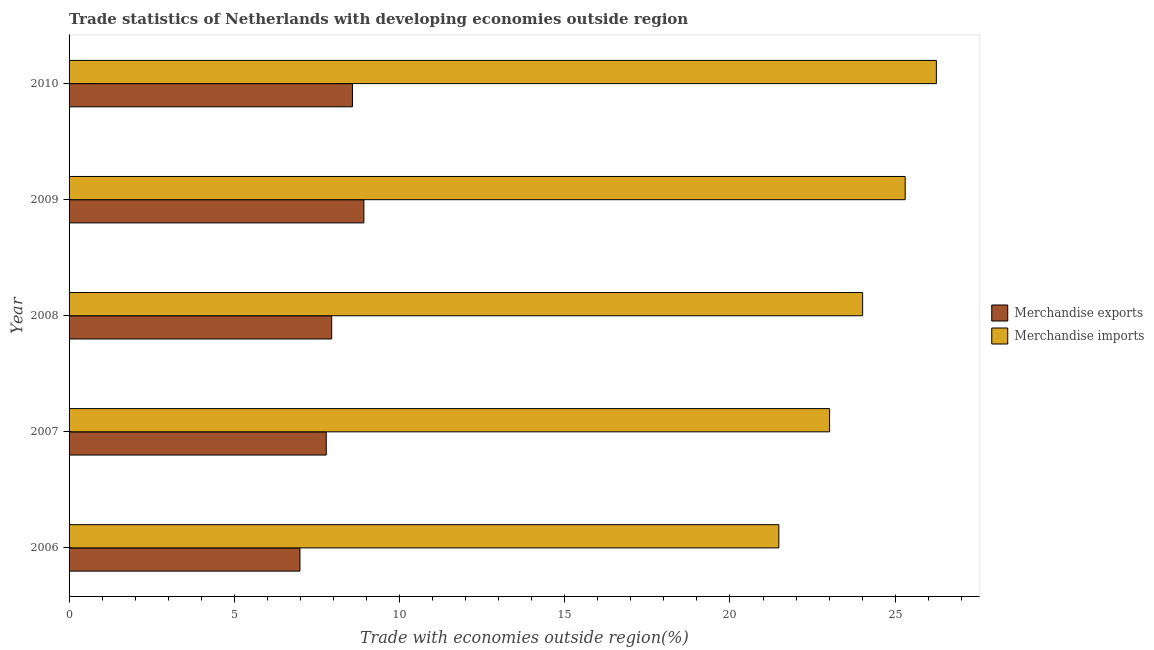How many different coloured bars are there?
Keep it short and to the point. 2. How many groups of bars are there?
Ensure brevity in your answer.  5. Are the number of bars per tick equal to the number of legend labels?
Give a very brief answer. Yes. Are the number of bars on each tick of the Y-axis equal?
Provide a succinct answer. Yes. How many bars are there on the 1st tick from the top?
Give a very brief answer. 2. What is the label of the 4th group of bars from the top?
Keep it short and to the point. 2007. What is the merchandise imports in 2006?
Offer a very short reply. 21.48. Across all years, what is the maximum merchandise exports?
Keep it short and to the point. 8.92. Across all years, what is the minimum merchandise exports?
Ensure brevity in your answer.  6.99. In which year was the merchandise imports maximum?
Provide a short and direct response. 2010. In which year was the merchandise exports minimum?
Your answer should be very brief. 2006. What is the total merchandise exports in the graph?
Provide a short and direct response. 40.21. What is the difference between the merchandise exports in 2007 and that in 2009?
Provide a succinct answer. -1.14. What is the difference between the merchandise exports in 2006 and the merchandise imports in 2010?
Your answer should be very brief. -19.26. What is the average merchandise imports per year?
Ensure brevity in your answer.  24.01. In the year 2008, what is the difference between the merchandise exports and merchandise imports?
Your answer should be compact. -16.07. What is the ratio of the merchandise imports in 2006 to that in 2007?
Your response must be concise. 0.93. Is the merchandise exports in 2006 less than that in 2007?
Your answer should be very brief. Yes. Is the difference between the merchandise imports in 2008 and 2010 greater than the difference between the merchandise exports in 2008 and 2010?
Offer a terse response. No. What is the difference between the highest and the second highest merchandise exports?
Provide a succinct answer. 0.35. What is the difference between the highest and the lowest merchandise exports?
Your answer should be very brief. 1.93. In how many years, is the merchandise exports greater than the average merchandise exports taken over all years?
Keep it short and to the point. 2. Is the sum of the merchandise exports in 2008 and 2009 greater than the maximum merchandise imports across all years?
Your response must be concise. No. What does the 1st bar from the top in 2007 represents?
Give a very brief answer. Merchandise imports. What does the 2nd bar from the bottom in 2006 represents?
Offer a terse response. Merchandise imports. How many bars are there?
Keep it short and to the point. 10. How many years are there in the graph?
Ensure brevity in your answer.  5. What is the difference between two consecutive major ticks on the X-axis?
Ensure brevity in your answer.  5. Are the values on the major ticks of X-axis written in scientific E-notation?
Make the answer very short. No. Where does the legend appear in the graph?
Your answer should be very brief. Center right. What is the title of the graph?
Your answer should be very brief. Trade statistics of Netherlands with developing economies outside region. Does "Commercial service imports" appear as one of the legend labels in the graph?
Provide a short and direct response. No. What is the label or title of the X-axis?
Your answer should be very brief. Trade with economies outside region(%). What is the label or title of the Y-axis?
Provide a short and direct response. Year. What is the Trade with economies outside region(%) in Merchandise exports in 2006?
Offer a terse response. 6.99. What is the Trade with economies outside region(%) of Merchandise imports in 2006?
Offer a very short reply. 21.48. What is the Trade with economies outside region(%) in Merchandise exports in 2007?
Ensure brevity in your answer.  7.78. What is the Trade with economies outside region(%) of Merchandise imports in 2007?
Your answer should be compact. 23.01. What is the Trade with economies outside region(%) in Merchandise exports in 2008?
Offer a terse response. 7.95. What is the Trade with economies outside region(%) in Merchandise imports in 2008?
Give a very brief answer. 24.01. What is the Trade with economies outside region(%) in Merchandise exports in 2009?
Your answer should be compact. 8.92. What is the Trade with economies outside region(%) of Merchandise imports in 2009?
Your response must be concise. 25.3. What is the Trade with economies outside region(%) in Merchandise exports in 2010?
Provide a succinct answer. 8.58. What is the Trade with economies outside region(%) of Merchandise imports in 2010?
Offer a terse response. 26.24. Across all years, what is the maximum Trade with economies outside region(%) in Merchandise exports?
Provide a short and direct response. 8.92. Across all years, what is the maximum Trade with economies outside region(%) of Merchandise imports?
Your answer should be very brief. 26.24. Across all years, what is the minimum Trade with economies outside region(%) of Merchandise exports?
Provide a short and direct response. 6.99. Across all years, what is the minimum Trade with economies outside region(%) in Merchandise imports?
Offer a very short reply. 21.48. What is the total Trade with economies outside region(%) of Merchandise exports in the graph?
Your answer should be compact. 40.21. What is the total Trade with economies outside region(%) in Merchandise imports in the graph?
Offer a very short reply. 120.05. What is the difference between the Trade with economies outside region(%) in Merchandise exports in 2006 and that in 2007?
Provide a short and direct response. -0.8. What is the difference between the Trade with economies outside region(%) in Merchandise imports in 2006 and that in 2007?
Ensure brevity in your answer.  -1.53. What is the difference between the Trade with economies outside region(%) in Merchandise exports in 2006 and that in 2008?
Offer a terse response. -0.96. What is the difference between the Trade with economies outside region(%) in Merchandise imports in 2006 and that in 2008?
Offer a very short reply. -2.54. What is the difference between the Trade with economies outside region(%) of Merchandise exports in 2006 and that in 2009?
Make the answer very short. -1.93. What is the difference between the Trade with economies outside region(%) in Merchandise imports in 2006 and that in 2009?
Offer a terse response. -3.82. What is the difference between the Trade with economies outside region(%) of Merchandise exports in 2006 and that in 2010?
Your answer should be compact. -1.59. What is the difference between the Trade with economies outside region(%) in Merchandise imports in 2006 and that in 2010?
Offer a very short reply. -4.77. What is the difference between the Trade with economies outside region(%) in Merchandise exports in 2007 and that in 2008?
Make the answer very short. -0.16. What is the difference between the Trade with economies outside region(%) in Merchandise imports in 2007 and that in 2008?
Your response must be concise. -1. What is the difference between the Trade with economies outside region(%) of Merchandise exports in 2007 and that in 2009?
Offer a terse response. -1.14. What is the difference between the Trade with economies outside region(%) of Merchandise imports in 2007 and that in 2009?
Your answer should be very brief. -2.29. What is the difference between the Trade with economies outside region(%) of Merchandise exports in 2007 and that in 2010?
Give a very brief answer. -0.79. What is the difference between the Trade with economies outside region(%) in Merchandise imports in 2007 and that in 2010?
Give a very brief answer. -3.23. What is the difference between the Trade with economies outside region(%) of Merchandise exports in 2008 and that in 2009?
Provide a succinct answer. -0.97. What is the difference between the Trade with economies outside region(%) in Merchandise imports in 2008 and that in 2009?
Your answer should be compact. -1.29. What is the difference between the Trade with economies outside region(%) in Merchandise exports in 2008 and that in 2010?
Your answer should be very brief. -0.63. What is the difference between the Trade with economies outside region(%) in Merchandise imports in 2008 and that in 2010?
Provide a succinct answer. -2.23. What is the difference between the Trade with economies outside region(%) of Merchandise exports in 2009 and that in 2010?
Your answer should be very brief. 0.35. What is the difference between the Trade with economies outside region(%) in Merchandise imports in 2009 and that in 2010?
Provide a short and direct response. -0.94. What is the difference between the Trade with economies outside region(%) of Merchandise exports in 2006 and the Trade with economies outside region(%) of Merchandise imports in 2007?
Your answer should be very brief. -16.03. What is the difference between the Trade with economies outside region(%) in Merchandise exports in 2006 and the Trade with economies outside region(%) in Merchandise imports in 2008?
Your answer should be compact. -17.03. What is the difference between the Trade with economies outside region(%) of Merchandise exports in 2006 and the Trade with economies outside region(%) of Merchandise imports in 2009?
Make the answer very short. -18.32. What is the difference between the Trade with economies outside region(%) of Merchandise exports in 2006 and the Trade with economies outside region(%) of Merchandise imports in 2010?
Your response must be concise. -19.26. What is the difference between the Trade with economies outside region(%) in Merchandise exports in 2007 and the Trade with economies outside region(%) in Merchandise imports in 2008?
Give a very brief answer. -16.23. What is the difference between the Trade with economies outside region(%) in Merchandise exports in 2007 and the Trade with economies outside region(%) in Merchandise imports in 2009?
Provide a succinct answer. -17.52. What is the difference between the Trade with economies outside region(%) of Merchandise exports in 2007 and the Trade with economies outside region(%) of Merchandise imports in 2010?
Ensure brevity in your answer.  -18.46. What is the difference between the Trade with economies outside region(%) in Merchandise exports in 2008 and the Trade with economies outside region(%) in Merchandise imports in 2009?
Offer a terse response. -17.36. What is the difference between the Trade with economies outside region(%) of Merchandise exports in 2008 and the Trade with economies outside region(%) of Merchandise imports in 2010?
Offer a very short reply. -18.3. What is the difference between the Trade with economies outside region(%) in Merchandise exports in 2009 and the Trade with economies outside region(%) in Merchandise imports in 2010?
Your answer should be very brief. -17.32. What is the average Trade with economies outside region(%) in Merchandise exports per year?
Keep it short and to the point. 8.04. What is the average Trade with economies outside region(%) in Merchandise imports per year?
Your answer should be compact. 24.01. In the year 2006, what is the difference between the Trade with economies outside region(%) in Merchandise exports and Trade with economies outside region(%) in Merchandise imports?
Provide a succinct answer. -14.49. In the year 2007, what is the difference between the Trade with economies outside region(%) in Merchandise exports and Trade with economies outside region(%) in Merchandise imports?
Ensure brevity in your answer.  -15.23. In the year 2008, what is the difference between the Trade with economies outside region(%) of Merchandise exports and Trade with economies outside region(%) of Merchandise imports?
Offer a terse response. -16.07. In the year 2009, what is the difference between the Trade with economies outside region(%) in Merchandise exports and Trade with economies outside region(%) in Merchandise imports?
Ensure brevity in your answer.  -16.38. In the year 2010, what is the difference between the Trade with economies outside region(%) in Merchandise exports and Trade with economies outside region(%) in Merchandise imports?
Make the answer very short. -17.67. What is the ratio of the Trade with economies outside region(%) of Merchandise exports in 2006 to that in 2007?
Give a very brief answer. 0.9. What is the ratio of the Trade with economies outside region(%) of Merchandise imports in 2006 to that in 2007?
Keep it short and to the point. 0.93. What is the ratio of the Trade with economies outside region(%) of Merchandise exports in 2006 to that in 2008?
Provide a succinct answer. 0.88. What is the ratio of the Trade with economies outside region(%) in Merchandise imports in 2006 to that in 2008?
Make the answer very short. 0.89. What is the ratio of the Trade with economies outside region(%) in Merchandise exports in 2006 to that in 2009?
Provide a short and direct response. 0.78. What is the ratio of the Trade with economies outside region(%) in Merchandise imports in 2006 to that in 2009?
Your answer should be very brief. 0.85. What is the ratio of the Trade with economies outside region(%) of Merchandise exports in 2006 to that in 2010?
Keep it short and to the point. 0.81. What is the ratio of the Trade with economies outside region(%) of Merchandise imports in 2006 to that in 2010?
Provide a short and direct response. 0.82. What is the ratio of the Trade with economies outside region(%) in Merchandise exports in 2007 to that in 2008?
Offer a terse response. 0.98. What is the ratio of the Trade with economies outside region(%) of Merchandise exports in 2007 to that in 2009?
Give a very brief answer. 0.87. What is the ratio of the Trade with economies outside region(%) of Merchandise imports in 2007 to that in 2009?
Your response must be concise. 0.91. What is the ratio of the Trade with economies outside region(%) in Merchandise exports in 2007 to that in 2010?
Ensure brevity in your answer.  0.91. What is the ratio of the Trade with economies outside region(%) of Merchandise imports in 2007 to that in 2010?
Provide a succinct answer. 0.88. What is the ratio of the Trade with economies outside region(%) in Merchandise exports in 2008 to that in 2009?
Keep it short and to the point. 0.89. What is the ratio of the Trade with economies outside region(%) of Merchandise imports in 2008 to that in 2009?
Offer a very short reply. 0.95. What is the ratio of the Trade with economies outside region(%) of Merchandise exports in 2008 to that in 2010?
Keep it short and to the point. 0.93. What is the ratio of the Trade with economies outside region(%) in Merchandise imports in 2008 to that in 2010?
Your response must be concise. 0.92. What is the ratio of the Trade with economies outside region(%) of Merchandise exports in 2009 to that in 2010?
Offer a terse response. 1.04. What is the ratio of the Trade with economies outside region(%) of Merchandise imports in 2009 to that in 2010?
Offer a terse response. 0.96. What is the difference between the highest and the second highest Trade with economies outside region(%) of Merchandise exports?
Ensure brevity in your answer.  0.35. What is the difference between the highest and the second highest Trade with economies outside region(%) in Merchandise imports?
Your answer should be compact. 0.94. What is the difference between the highest and the lowest Trade with economies outside region(%) of Merchandise exports?
Your answer should be very brief. 1.93. What is the difference between the highest and the lowest Trade with economies outside region(%) in Merchandise imports?
Offer a terse response. 4.77. 